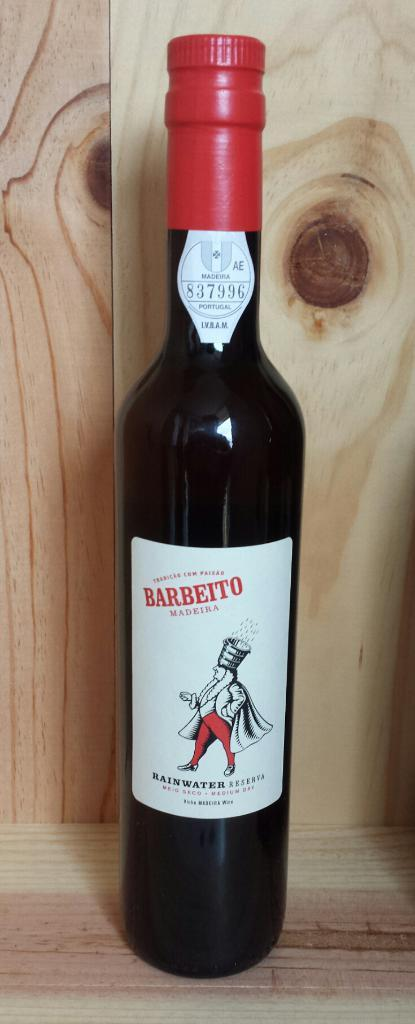<image>
Present a compact description of the photo's key features. An unopened bottle of medium dry wine sits on a wood surface. 